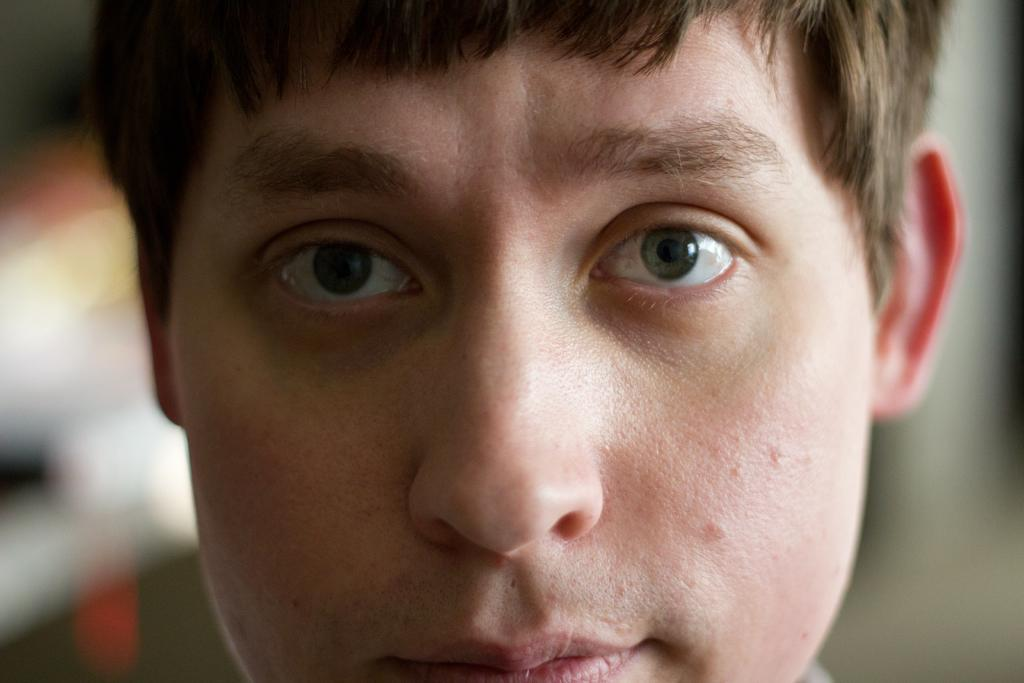What is the main subject of the image? There is a person's face in the image. Can you describe the background of the image? The background of the image is blurry. What type of low-fat food can be seen in the image? There is no low-fat food present in the image; it features a person's face with a blurry background. 